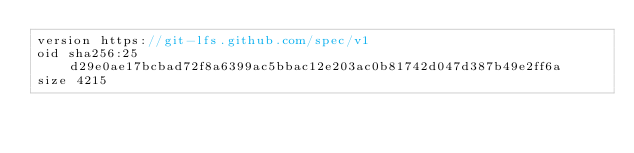<code> <loc_0><loc_0><loc_500><loc_500><_C#_>version https://git-lfs.github.com/spec/v1
oid sha256:25d29e0ae17bcbad72f8a6399ac5bbac12e203ac0b81742d047d387b49e2ff6a
size 4215
</code> 